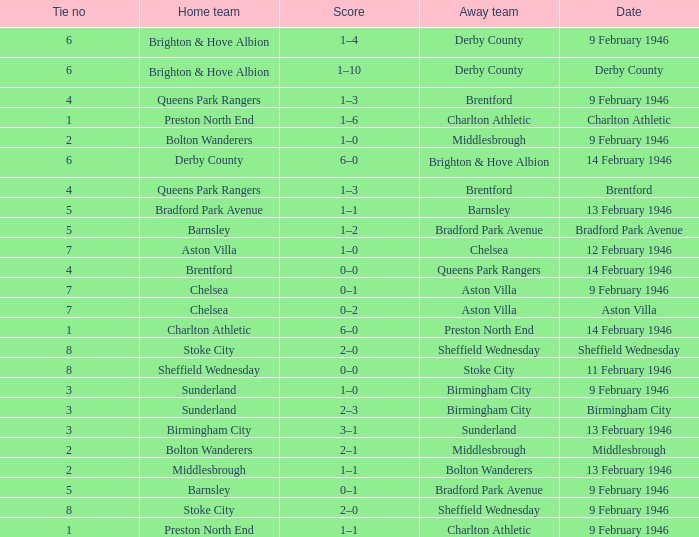What is the average Tie no when the date is Birmingham City? 3.0. 